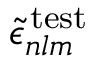<formula> <loc_0><loc_0><loc_500><loc_500>\widetilde { \epsilon } _ { n l m } ^ { \, t e s t }</formula> 